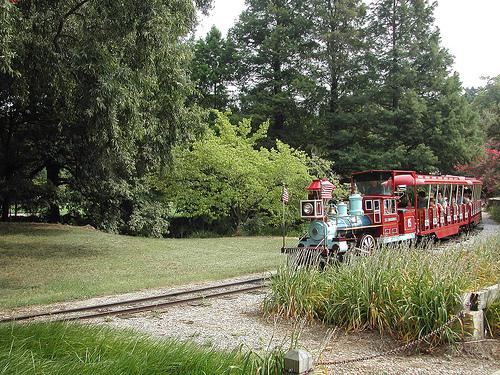Question: who is seen vaguely in this photo?
Choices:
A. People.
B. A man.
C. A woman.
D. Michael Jordan.
Answer with the letter. Answer: A Question: what are the people riding on?
Choices:
A. Bus.
B. Train.
C. Wagon.
D. Plane.
Answer with the letter. Answer: B Question: what color is part of train that people are vaguely seen in?
Choices:
A. Red.
B. Black.
C. Purple.
D. Gray.
Answer with the letter. Answer: A Question: when was this photo taken?
Choices:
A. Yesterday.
B. Daylight.
C. Today.
D. Noon.
Answer with the letter. Answer: B Question: why is chain across path in foreground of photo?
Choices:
A. To keep people out.
B. To prevent walking on track.
C. Safety.
D. Path is closed.
Answer with the letter. Answer: B Question: what is seen in the background other than sky?
Choices:
A. Mountains.
B. Trees.
C. Buildings.
D. Ocean.
Answer with the letter. Answer: B 